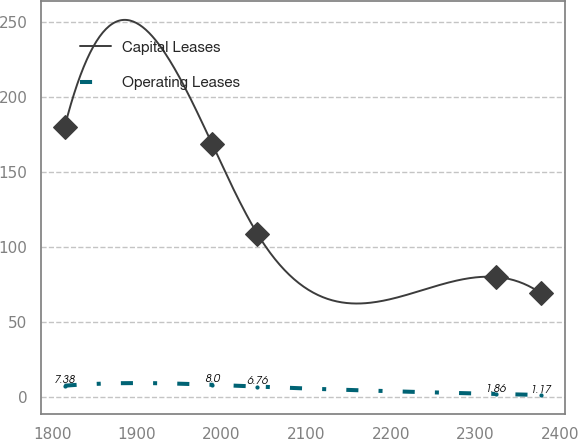<chart> <loc_0><loc_0><loc_500><loc_500><line_chart><ecel><fcel>Capital Leases<fcel>Operating Leases<nl><fcel>1814.45<fcel>180.01<fcel>7.38<nl><fcel>1988.67<fcel>169.09<fcel>8<nl><fcel>2042.16<fcel>109<fcel>6.76<nl><fcel>2324.11<fcel>79.99<fcel>1.86<nl><fcel>2377.6<fcel>69.07<fcel>1.17<nl></chart> 